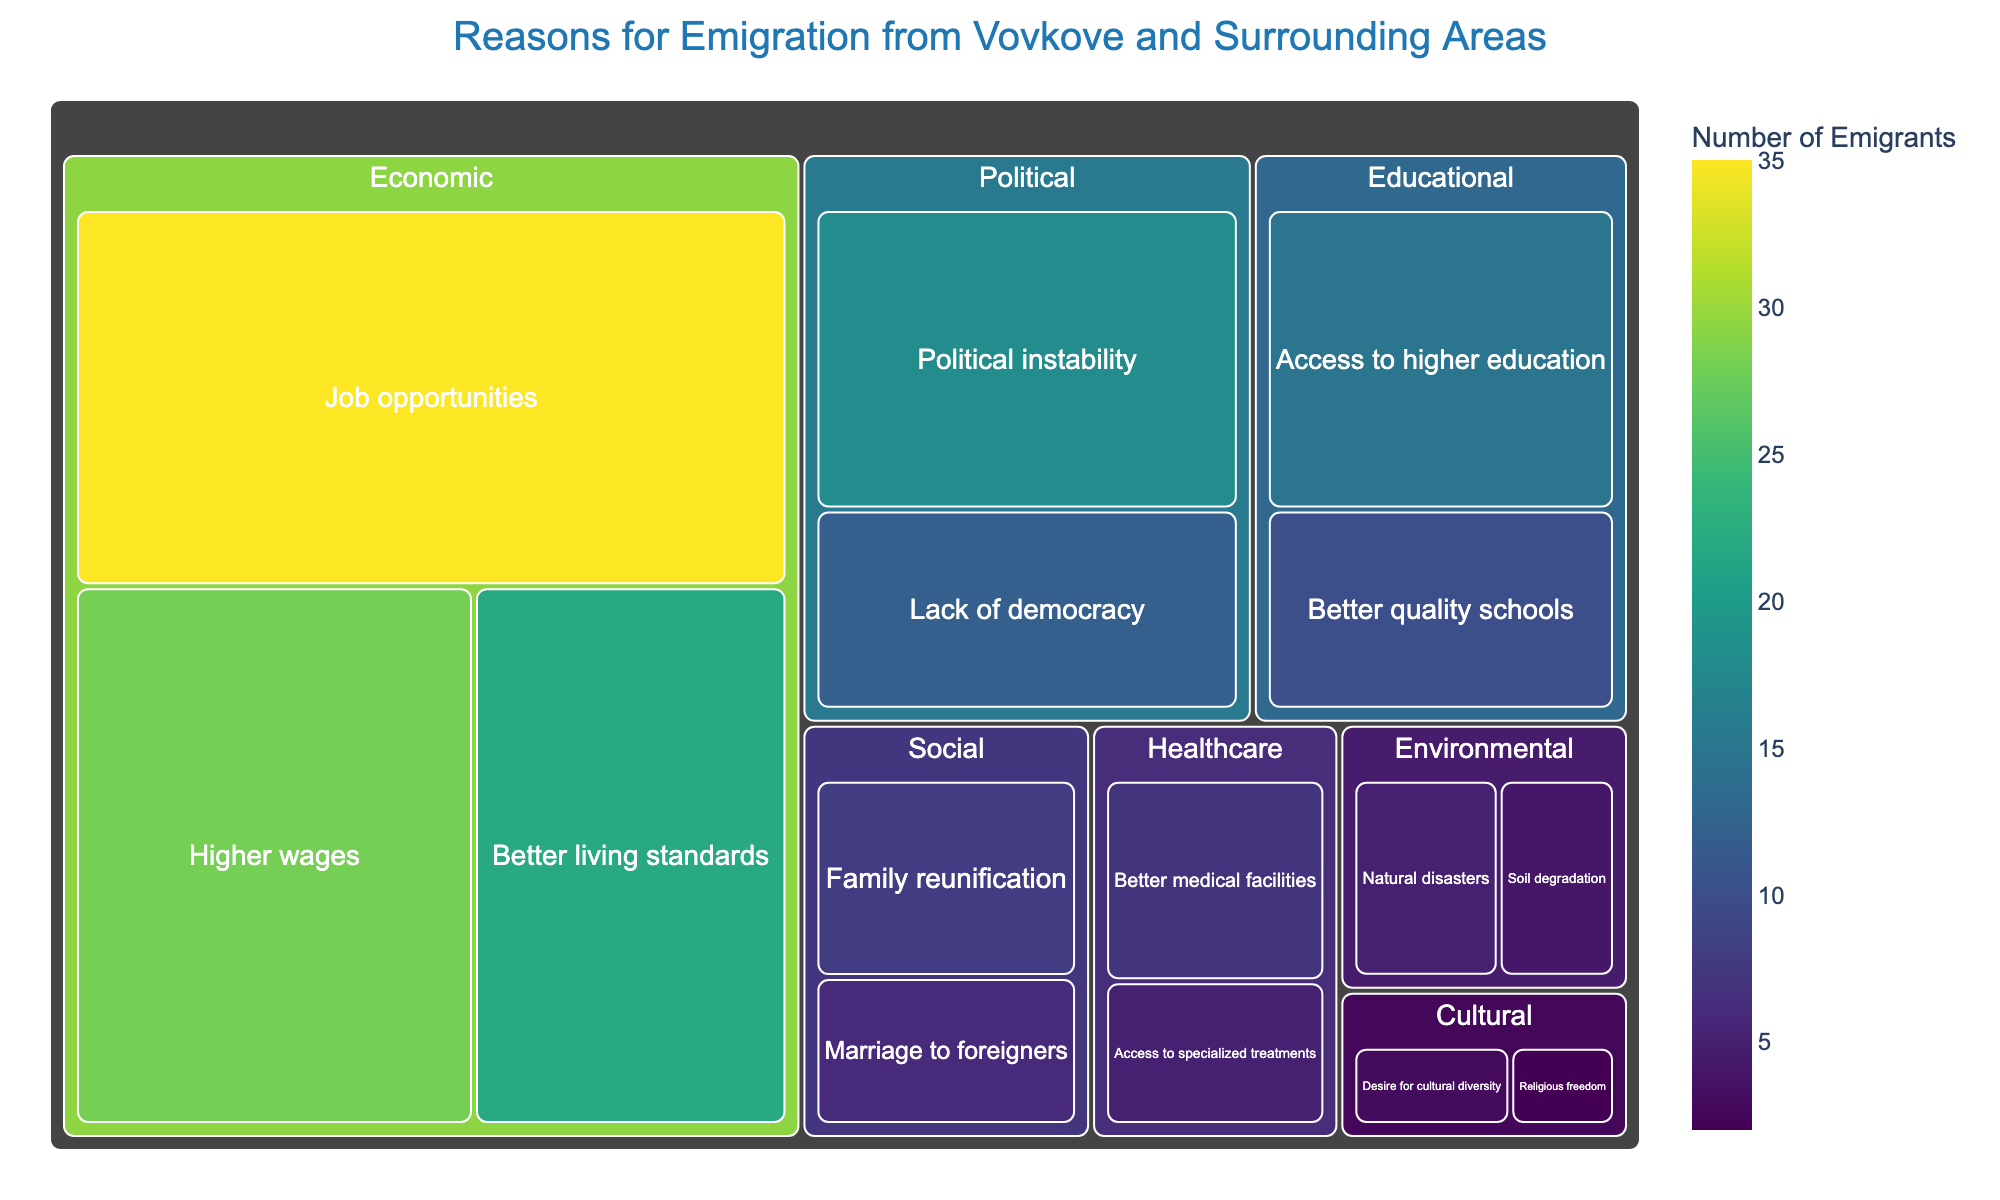What is the most common reason for emigration from Vovkove and surrounding areas? By looking at the largest segment in the treemap, the most common reason for emigration is "Job opportunities" under the Economic category, with the highest number of emigrants.
Answer: Job opportunities Which category has the least significance in the reasons for emigration? By comparing the smallest segments in the treemap, the Cultural category has the least significance with the smallest values, namely "Desire for cultural diversity" and "Religious freedom".
Answer: Cultural What is the total number of people who emigrated for economic reasons? Add the values of all subcategories under the Economic category: Job opportunities (35) + Higher wages (28) + Better living standards (22) = 85
Answer: 85 How does the significance of "Access to higher education" compare to "Political instability" as a reason for emigration? By comparing their sizes in the treemap, "Access to higher education" (15) has fewer emigrants than "Political instability" (18).
Answer: Less What are the top three reasons for emigration? Identify the three largest segments in the treemap: "Job opportunities" (35), "Higher wages" (28), and "Better living standards" (22).
Answer: Job opportunities, Higher wages, Better living standards What percent of emigrants left due to healthcare-related reasons? Sum the values for healthcare reasons and divide by the total number of emigrants: (Better medical facilities (7) + Access to specialized treatments (5)) / Total emigrants (171) x 100 = (12 / 171) x 100 ≈ 7.02%
Answer: 7.02% Are there more people emigrating due to social reasons or environmental reasons? Compare the totals for Social and Environmental categories: Social (Family reunification (8) + Marriage to foreigners (6) = 14) vs. Environmental (Natural disasters (5) + Soil degradation (4) = 9). Social reasons have more people.
Answer: Social What is the combined percentage of emigrants who left due to political or economic reasons? Calculate the total for political and economic reasons and divide by the total number of emigrants: (Economic (85) + Political (30)) / Total emigrants (171) x 100 = (115 / 171) x 100 ≈ 67.25%
Answer: 67.25% Which healthcare reason has more emigrants, "Better medical facilities" or "Access to specialized treatments"? Compare their values in the Healthcare category: Better medical facilities (7) is greater than Access to specialized treatments (5).
Answer: Better medical facilities 